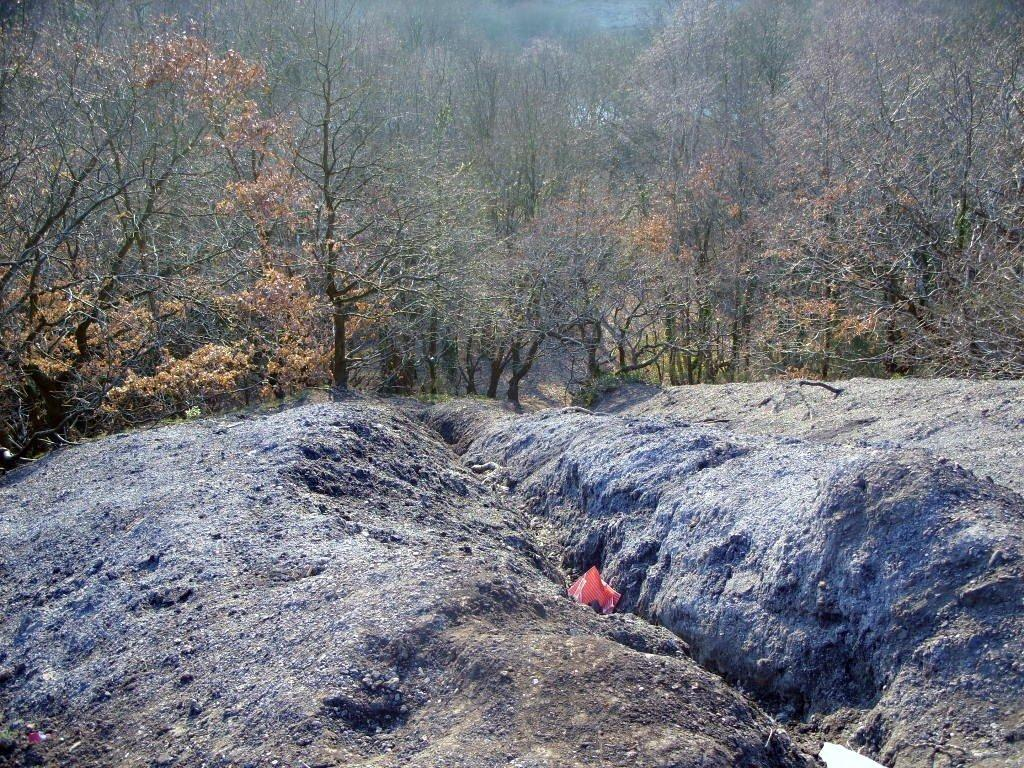What type of natural elements can be seen in the image? There are rocks in the image. What is the color of the prominent object in the image? There is a red color thing in the image. What can be seen in the distance in the image? There are trees in the background of the image. Can you tell me how many toes are visible on the rocks in the image? There are no toes present in the image; it features rocks and a red color thing. What type of creature owns the red color thing in the image? There is no creature or owner associated with the red color thing in the image. 